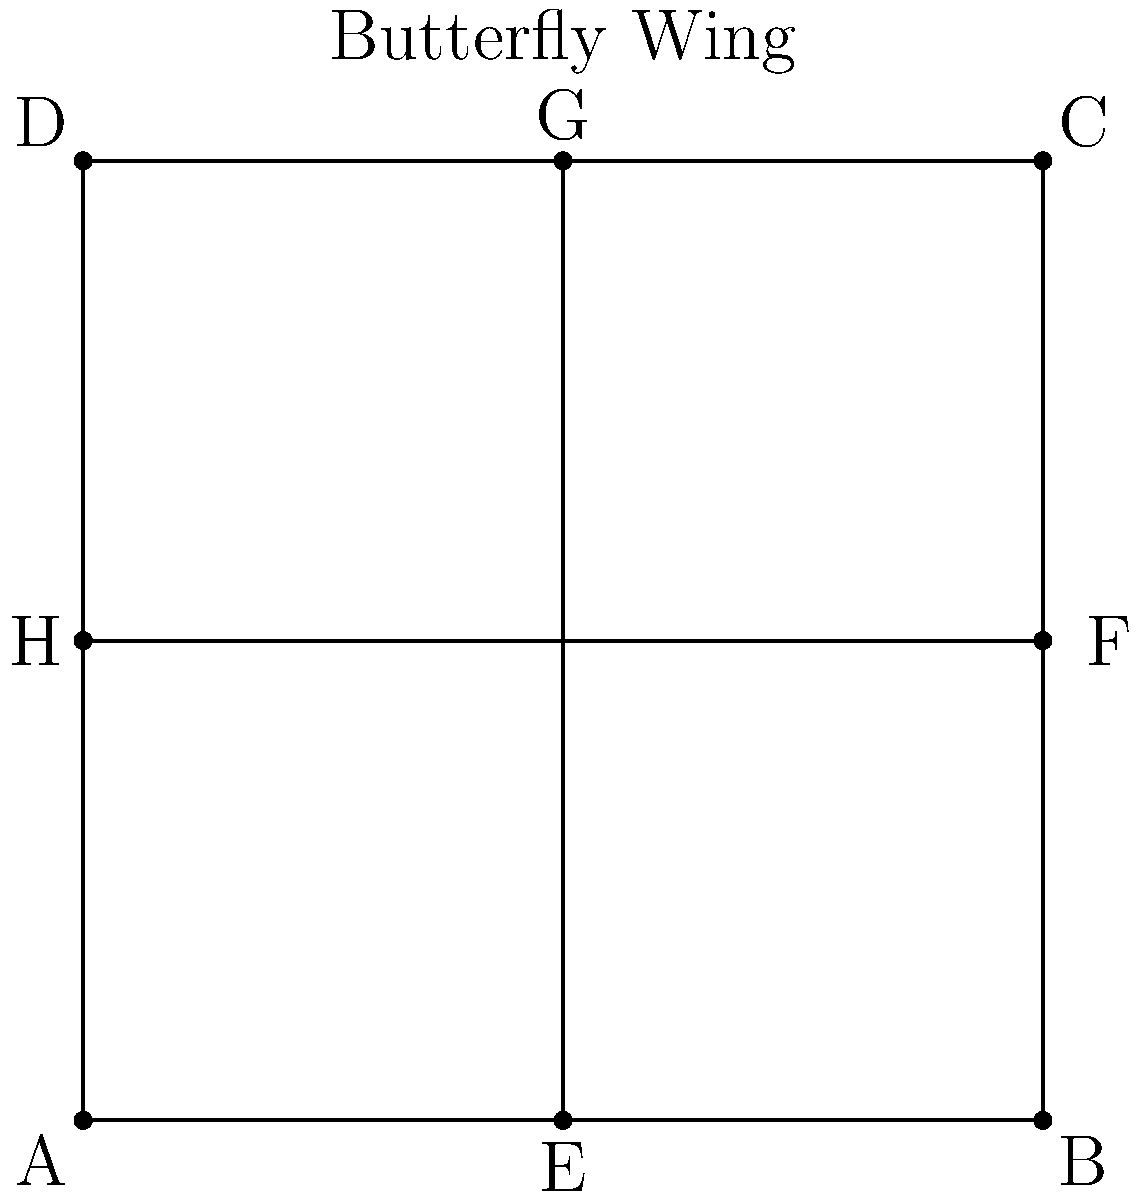In the whimsical world of butterfly symmetry, a poet notices a peculiar pattern on a wing. The wing is represented by a square ABCD with side length 4 units. Two lines intersect at the center, dividing the wing into four equal parts. If the poet were to write a verse about the area of one of these parts, what fraction of the total wing area would it represent? Express your answer as a poetic fraction. Let's unravel this butterfly's mystery with a touch of poetic mathematics:

1) First, we observe that the square ABCD represents the entire butterfly wing.

2) The area of the whole wing (square ABCD) is:
   $$A_{total} = 4 \times 4 = 16$$ square units

3) The two intersecting lines (EG and HF) divide the wing into four equal parts.

4) Since these parts are equal, each part must represent a fraction of the total area.

5) To find this fraction, we divide the total area by 4:
   $$A_{part} = \frac{A_{total}}{4} = \frac{16}{4} = 4$$ square units

6) Now, to express this as a fraction of the total area:
   $$\frac{A_{part}}{A_{total}} = \frac{4}{16} = \frac{1}{4}$$

7) In the language of poetry, we might say "a quarter" or "one-fourth" of the wing's area.

Thus, each part represents one-fourth of the butterfly's wing, a perfect symmetry for our poetic musings.
Answer: $\frac{1}{4}$ 